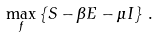Convert formula to latex. <formula><loc_0><loc_0><loc_500><loc_500>\max _ { f } \left \{ S - \beta E - \mu I \right \} \, .</formula> 